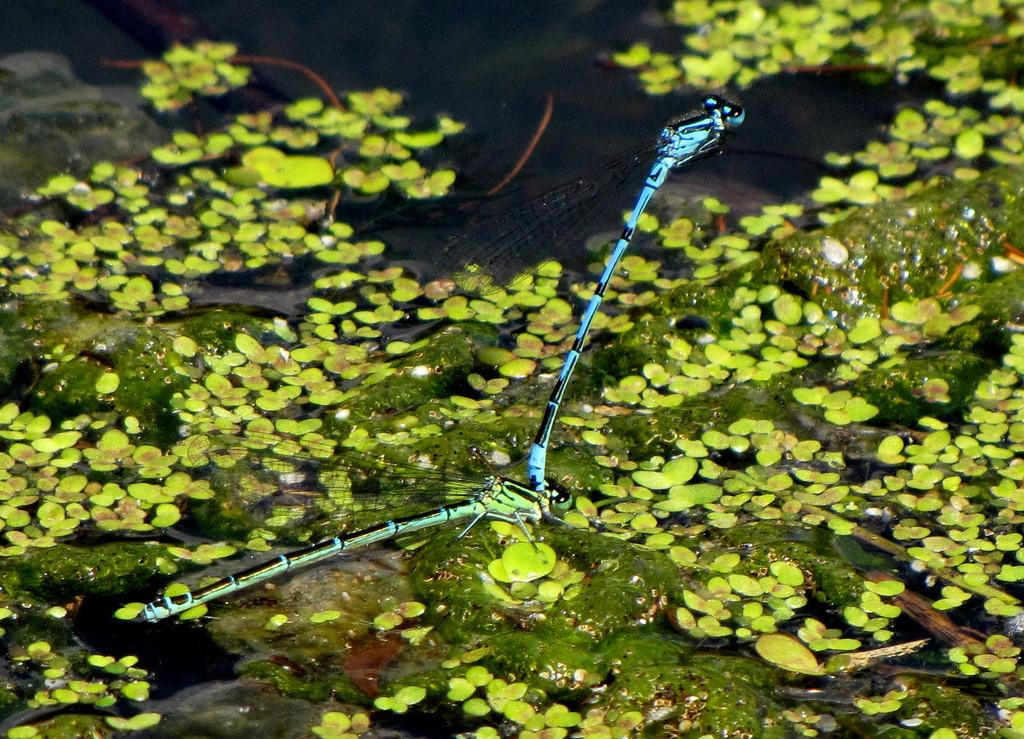What is present in the water in the image? There is algae in the water in the image. What else can be seen floating on the water? There are small leaves on the water. How many insects are visible in the image? There are two insects in the image. What type of motion can be observed in the end of the image? There is no motion or end present in the image; it is a still image of algae, leaves, and insects in water. How does the image show respect for the environment? The image itself does not show respect for the environment, as it is a still image and not an action or behavior. 